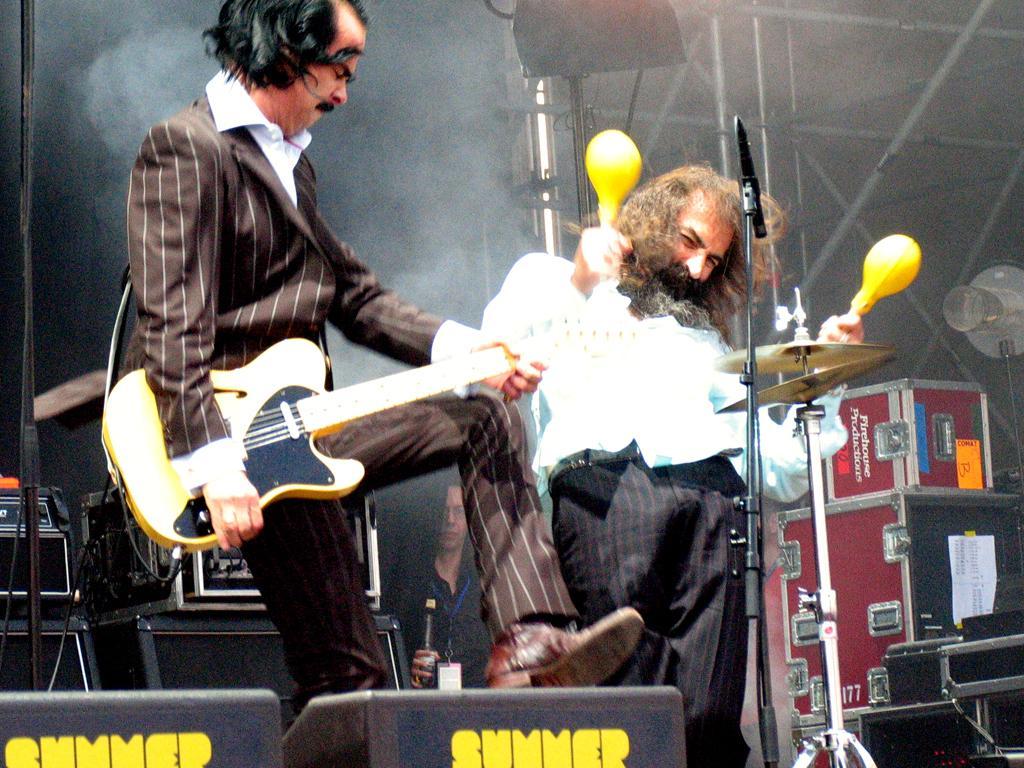Describe this image in one or two sentences. In this image I can see two men are standing where one is holding a guitar in his hand. I can also see a mic over here. 